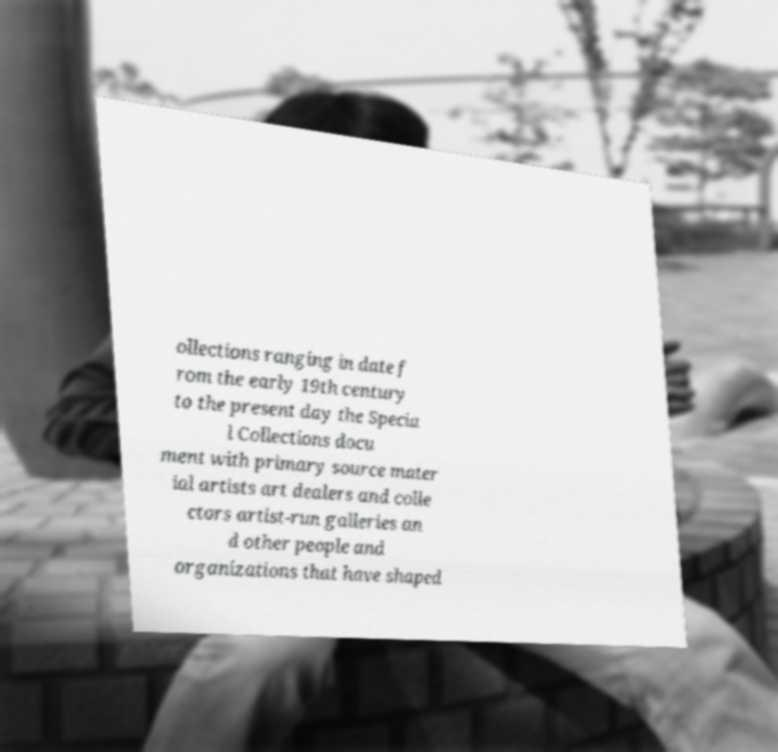Can you accurately transcribe the text from the provided image for me? ollections ranging in date f rom the early 19th century to the present day the Specia l Collections docu ment with primary source mater ial artists art dealers and colle ctors artist-run galleries an d other people and organizations that have shaped 